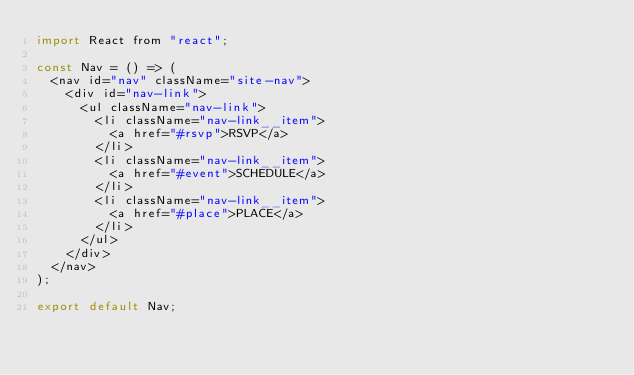<code> <loc_0><loc_0><loc_500><loc_500><_JavaScript_>import React from "react";

const Nav = () => (
  <nav id="nav" className="site-nav">
    <div id="nav-link">
      <ul className="nav-link">
        <li className="nav-link__item">
          <a href="#rsvp">RSVP</a>
        </li>
        <li className="nav-link__item">
          <a href="#event">SCHEDULE</a>
        </li>
        <li className="nav-link__item">
          <a href="#place">PLACE</a>
        </li>
      </ul>
    </div>
  </nav>
);

export default Nav;

</code> 